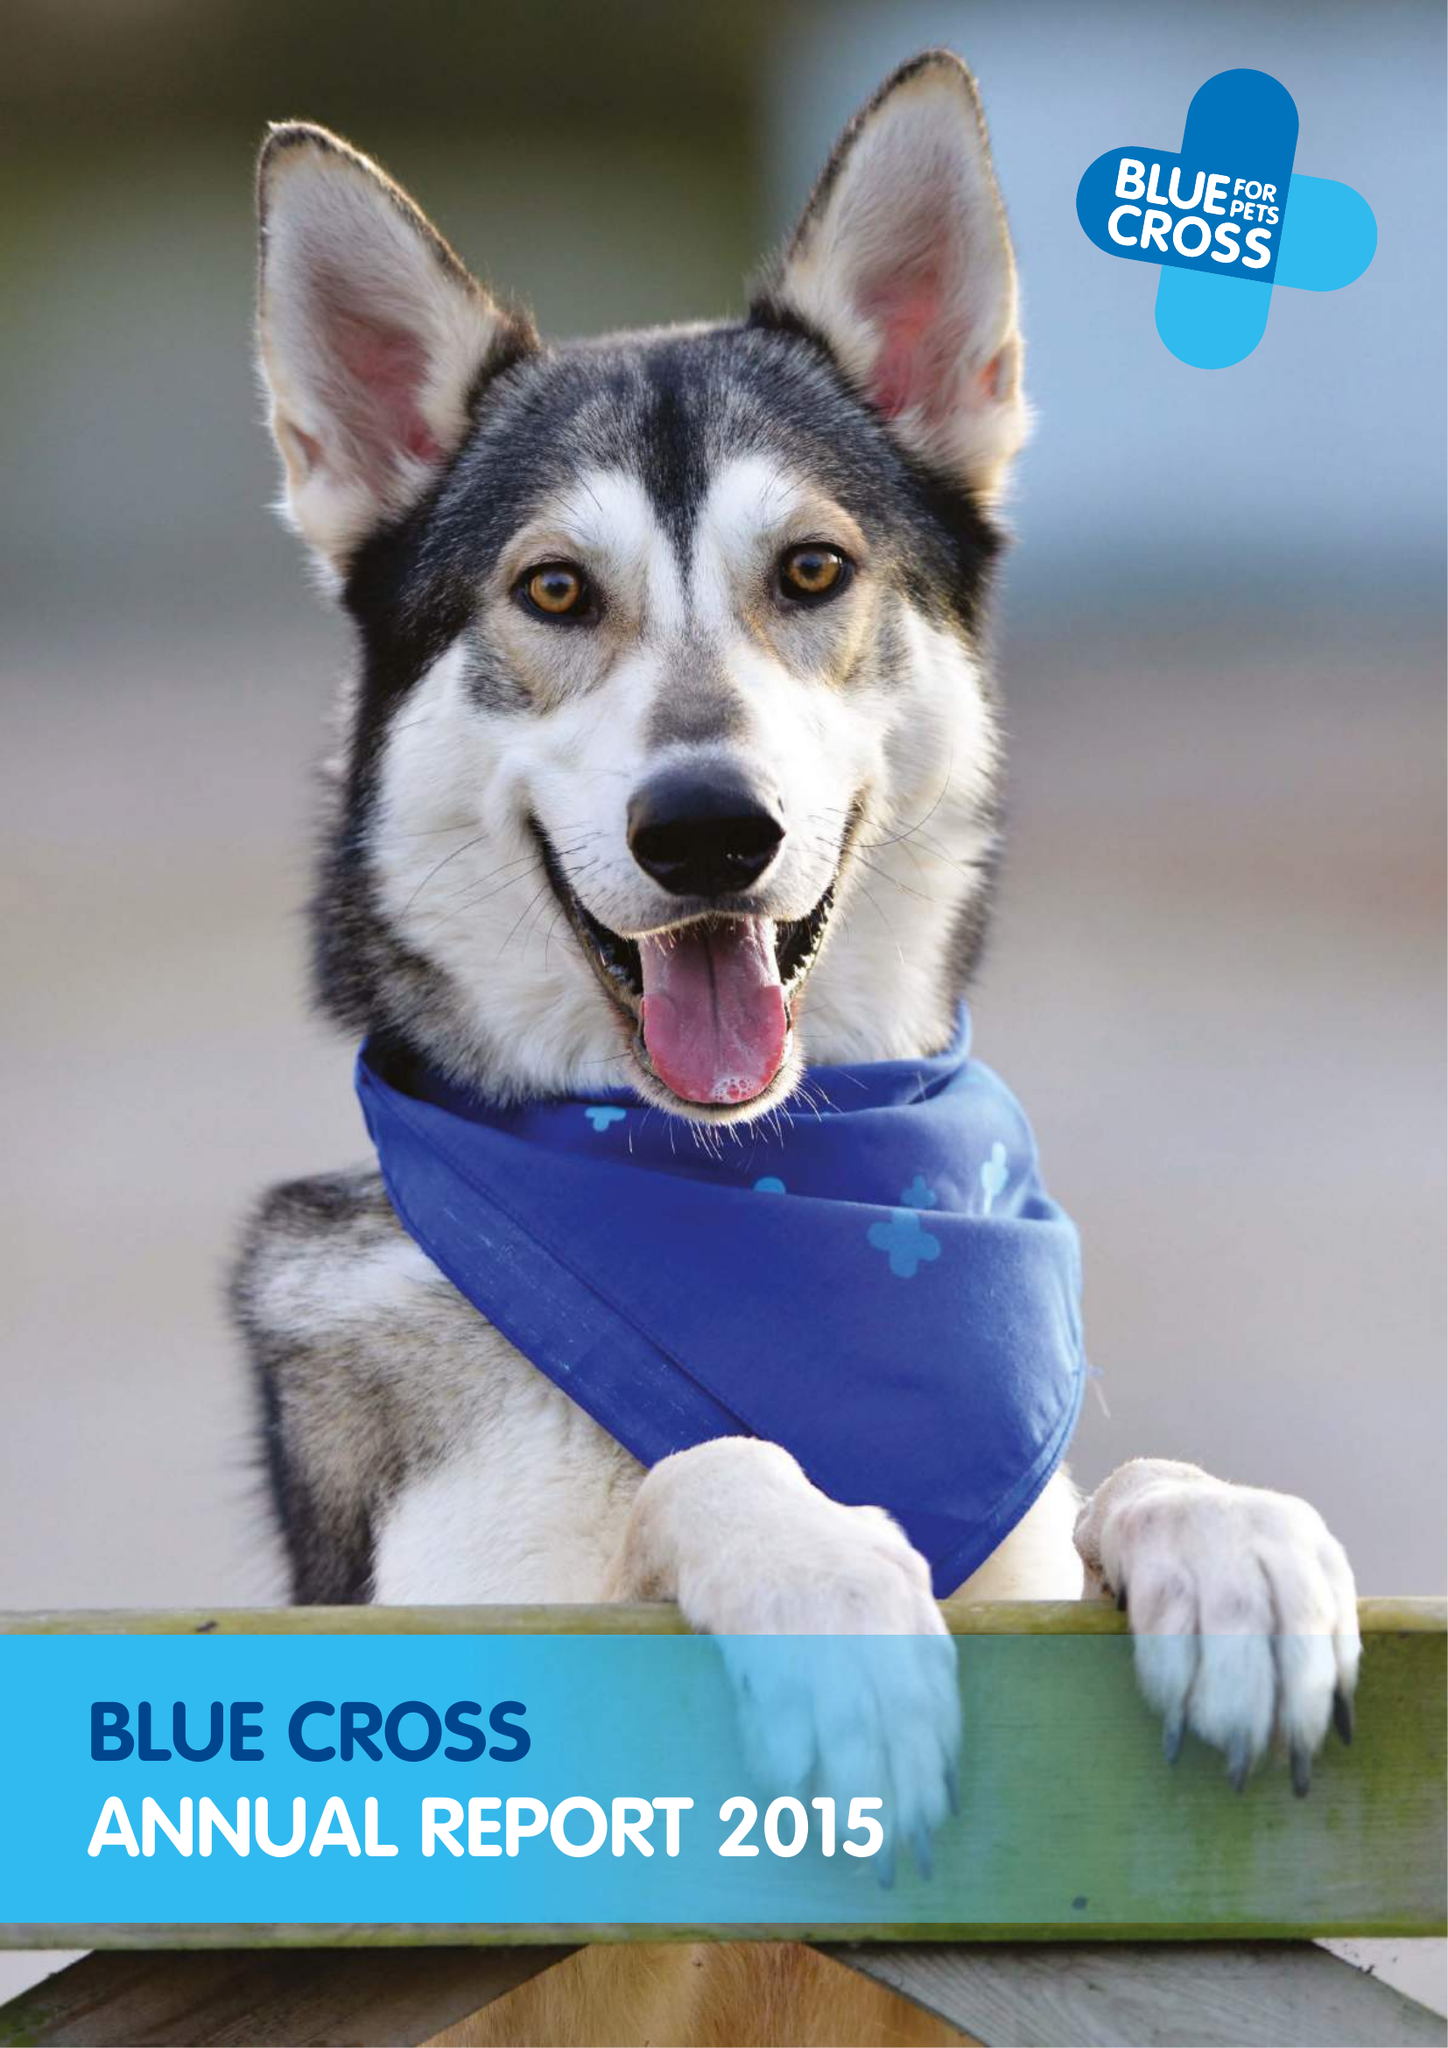What is the value for the charity_name?
Answer the question using a single word or phrase. Blue Cross 